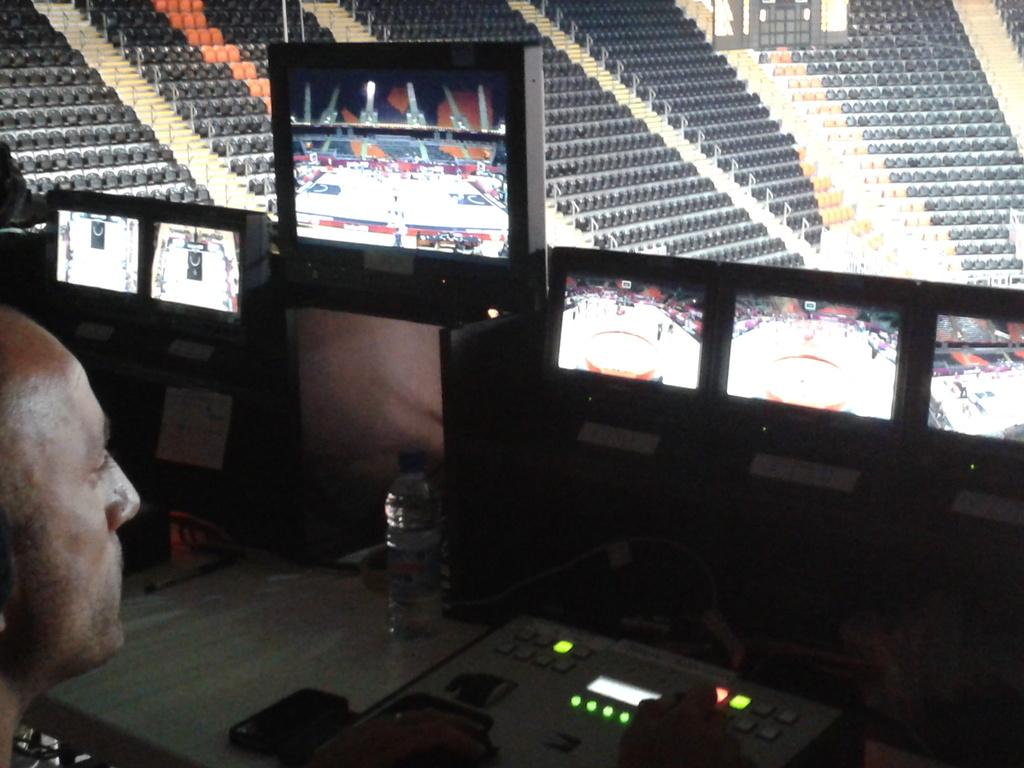What are the persons in the image doing? The persons in the image are sitting at the monitors on the left side. What can be seen on the table in the image? There is a water bottle and equipment on the table. What type of furniture is visible in the background of the image? There are chairs visible in the background of the image. What type of key is used to unlock the equipment in the image? There is no key present in the image, and the equipment does not require a key to operate. What type of drug is being used by the persons sitting at the monitors in the image? There is no drug use depicted in the image; the persons are simply sitting at the monitors. 